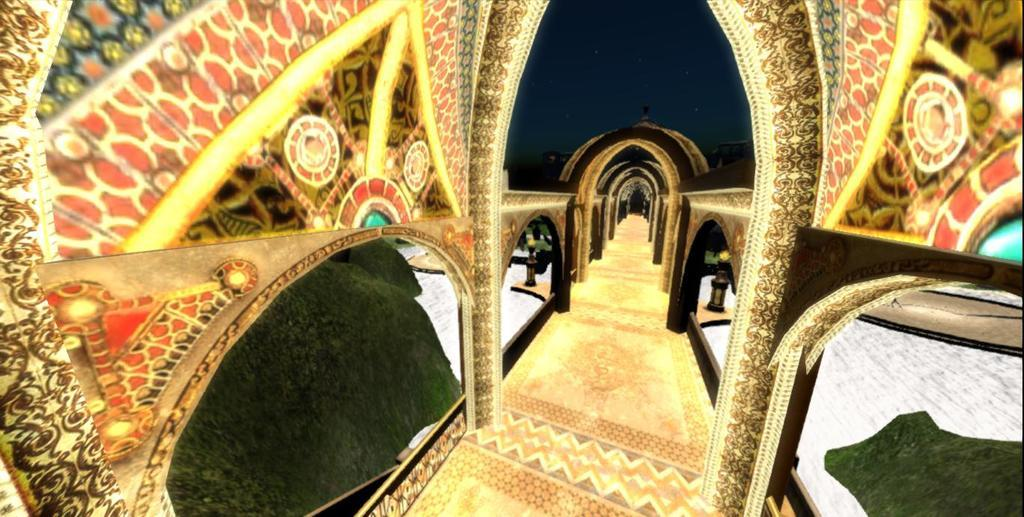What type of image can be seen in the picture? There is a graphical image in the picture. How many oranges are visible in the sea in the image? There are no oranges or sea present in the image; it contains a graphical image. What type of pie is being served in the image? There is no pie present in the image; it contains a graphical image. 